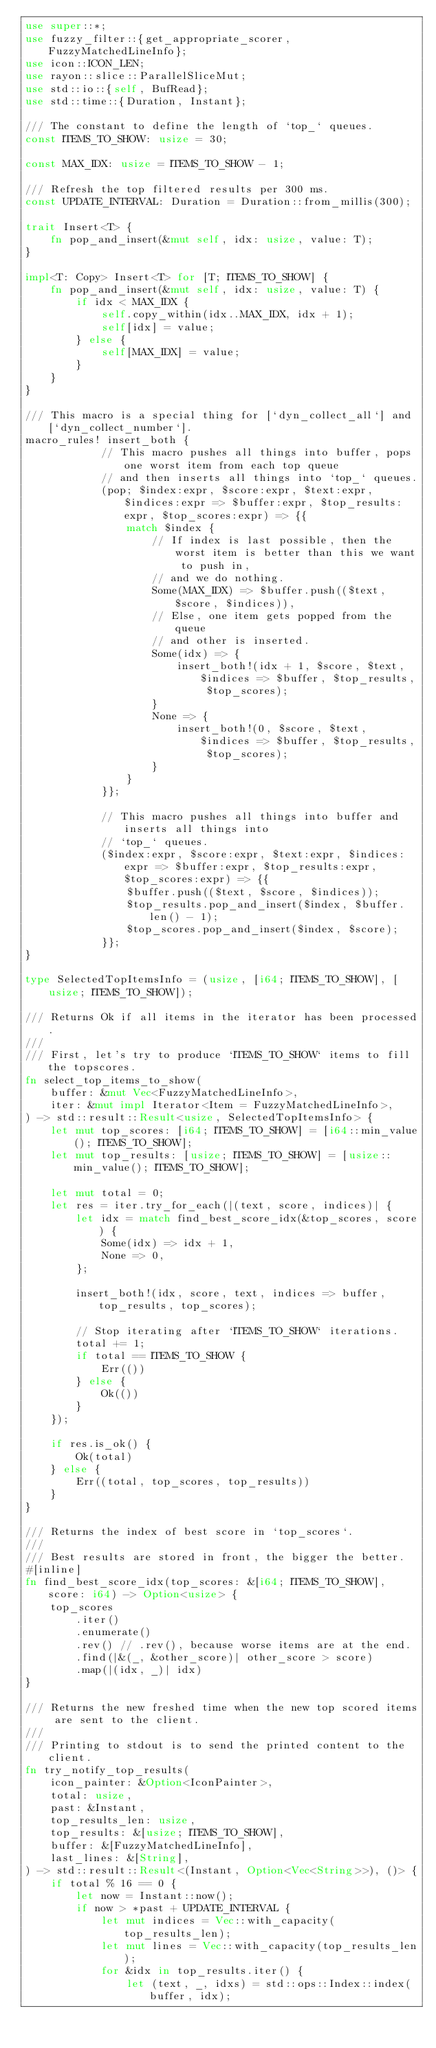<code> <loc_0><loc_0><loc_500><loc_500><_Rust_>use super::*;
use fuzzy_filter::{get_appropriate_scorer, FuzzyMatchedLineInfo};
use icon::ICON_LEN;
use rayon::slice::ParallelSliceMut;
use std::io::{self, BufRead};
use std::time::{Duration, Instant};

/// The constant to define the length of `top_` queues.
const ITEMS_TO_SHOW: usize = 30;

const MAX_IDX: usize = ITEMS_TO_SHOW - 1;

/// Refresh the top filtered results per 300 ms.
const UPDATE_INTERVAL: Duration = Duration::from_millis(300);

trait Insert<T> {
    fn pop_and_insert(&mut self, idx: usize, value: T);
}

impl<T: Copy> Insert<T> for [T; ITEMS_TO_SHOW] {
    fn pop_and_insert(&mut self, idx: usize, value: T) {
        if idx < MAX_IDX {
            self.copy_within(idx..MAX_IDX, idx + 1);
            self[idx] = value;
        } else {
            self[MAX_IDX] = value;
        }
    }
}

/// This macro is a special thing for [`dyn_collect_all`] and [`dyn_collect_number`].
macro_rules! insert_both {
            // This macro pushes all things into buffer, pops one worst item from each top queue
            // and then inserts all things into `top_` queues.
            (pop; $index:expr, $score:expr, $text:expr, $indices:expr => $buffer:expr, $top_results:expr, $top_scores:expr) => {{
                match $index {
                    // If index is last possible, then the worst item is better than this we want to push in,
                    // and we do nothing.
                    Some(MAX_IDX) => $buffer.push(($text, $score, $indices)),
                    // Else, one item gets popped from the queue
                    // and other is inserted.
                    Some(idx) => {
                        insert_both!(idx + 1, $score, $text, $indices => $buffer, $top_results, $top_scores);
                    }
                    None => {
                        insert_both!(0, $score, $text, $indices => $buffer, $top_results, $top_scores);
                    }
                }
            }};

            // This macro pushes all things into buffer and inserts all things into
            // `top_` queues.
            ($index:expr, $score:expr, $text:expr, $indices:expr => $buffer:expr, $top_results:expr, $top_scores:expr) => {{
                $buffer.push(($text, $score, $indices));
                $top_results.pop_and_insert($index, $buffer.len() - 1);
                $top_scores.pop_and_insert($index, $score);
            }};
}

type SelectedTopItemsInfo = (usize, [i64; ITEMS_TO_SHOW], [usize; ITEMS_TO_SHOW]);

/// Returns Ok if all items in the iterator has been processed.
///
/// First, let's try to produce `ITEMS_TO_SHOW` items to fill the topscores.
fn select_top_items_to_show(
    buffer: &mut Vec<FuzzyMatchedLineInfo>,
    iter: &mut impl Iterator<Item = FuzzyMatchedLineInfo>,
) -> std::result::Result<usize, SelectedTopItemsInfo> {
    let mut top_scores: [i64; ITEMS_TO_SHOW] = [i64::min_value(); ITEMS_TO_SHOW];
    let mut top_results: [usize; ITEMS_TO_SHOW] = [usize::min_value(); ITEMS_TO_SHOW];

    let mut total = 0;
    let res = iter.try_for_each(|(text, score, indices)| {
        let idx = match find_best_score_idx(&top_scores, score) {
            Some(idx) => idx + 1,
            None => 0,
        };

        insert_both!(idx, score, text, indices => buffer, top_results, top_scores);

        // Stop iterating after `ITEMS_TO_SHOW` iterations.
        total += 1;
        if total == ITEMS_TO_SHOW {
            Err(())
        } else {
            Ok(())
        }
    });

    if res.is_ok() {
        Ok(total)
    } else {
        Err((total, top_scores, top_results))
    }
}

/// Returns the index of best score in `top_scores`.
///
/// Best results are stored in front, the bigger the better.
#[inline]
fn find_best_score_idx(top_scores: &[i64; ITEMS_TO_SHOW], score: i64) -> Option<usize> {
    top_scores
        .iter()
        .enumerate()
        .rev() // .rev(), because worse items are at the end.
        .find(|&(_, &other_score)| other_score > score)
        .map(|(idx, _)| idx)
}

/// Returns the new freshed time when the new top scored items are sent to the client.
///
/// Printing to stdout is to send the printed content to the client.
fn try_notify_top_results(
    icon_painter: &Option<IconPainter>,
    total: usize,
    past: &Instant,
    top_results_len: usize,
    top_results: &[usize; ITEMS_TO_SHOW],
    buffer: &[FuzzyMatchedLineInfo],
    last_lines: &[String],
) -> std::result::Result<(Instant, Option<Vec<String>>), ()> {
    if total % 16 == 0 {
        let now = Instant::now();
        if now > *past + UPDATE_INTERVAL {
            let mut indices = Vec::with_capacity(top_results_len);
            let mut lines = Vec::with_capacity(top_results_len);
            for &idx in top_results.iter() {
                let (text, _, idxs) = std::ops::Index::index(buffer, idx);</code> 